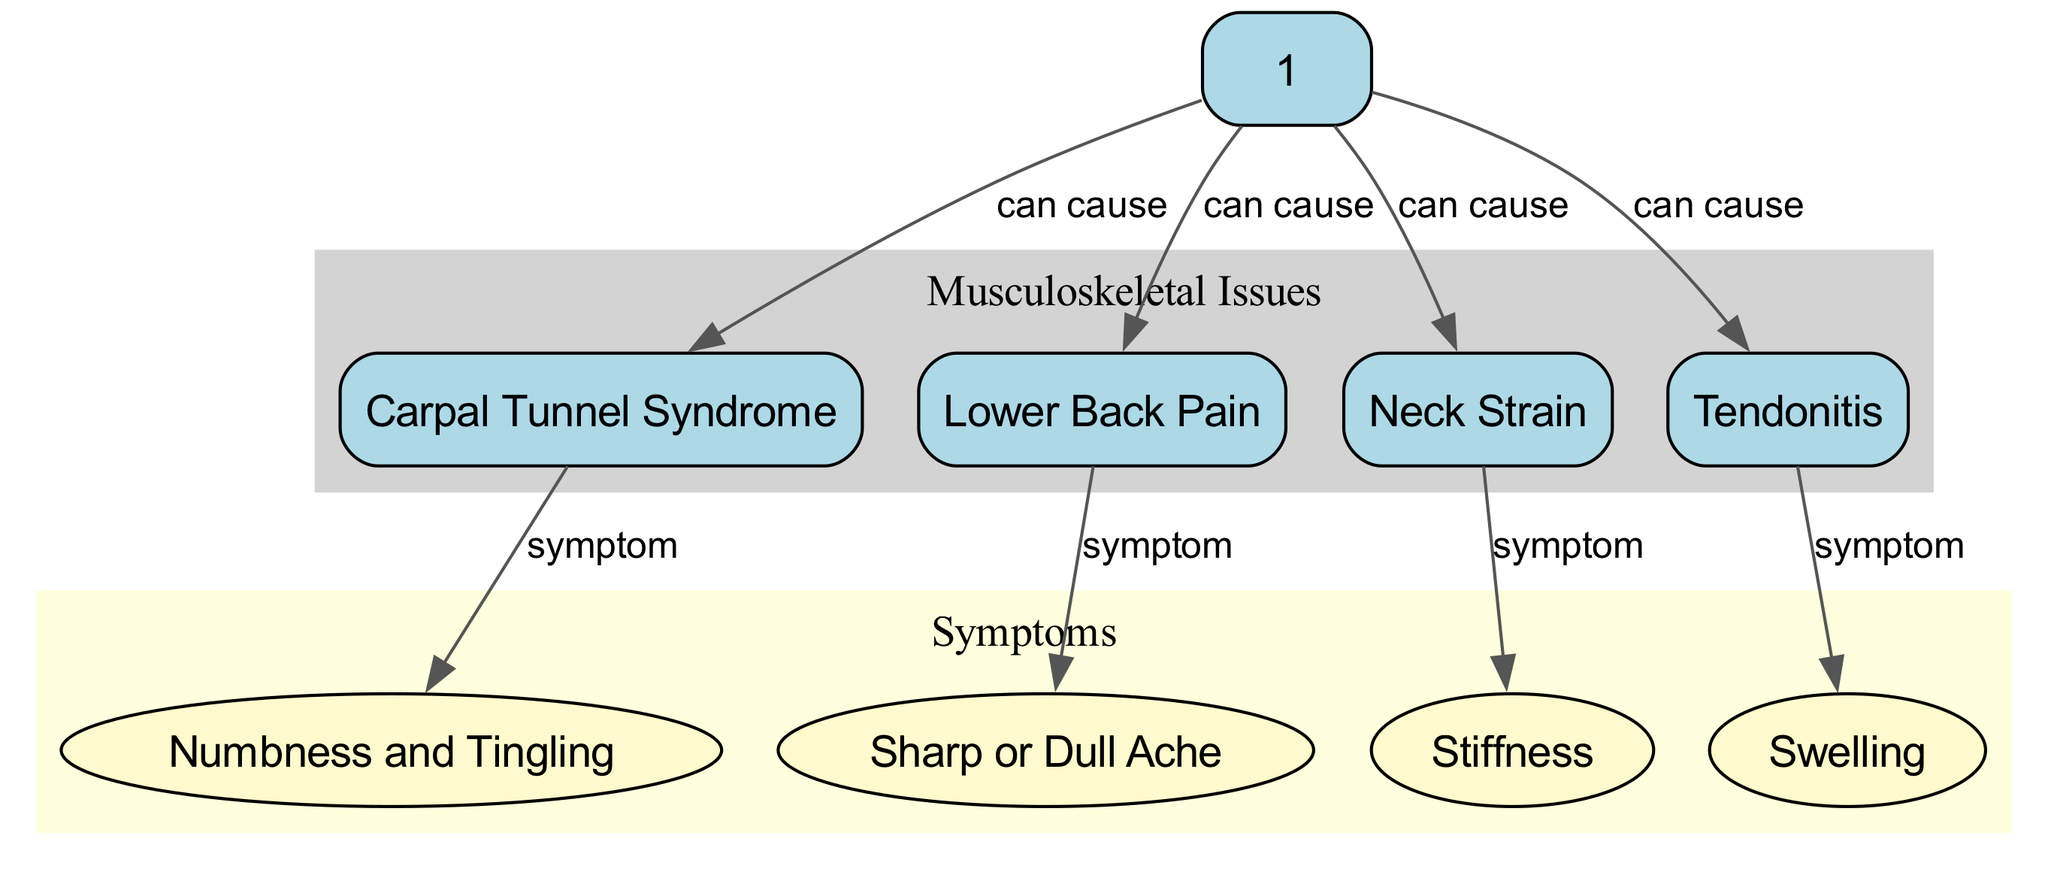What are the four musculoskeletal issues mentioned? The diagram lists four specific musculoskeletal issues which can be identified as nodes connected to the central node "Musculoskeletal Issues." These are Carpal Tunnel Syndrome, Lower Back Pain, Neck Strain, and Tendonitis.
Answer: Carpal Tunnel Syndrome, Lower Back Pain, Neck Strain, Tendonitis How many symptoms are identified in the diagram? The diagram includes four specific symptoms that are connected to the category "Symptoms." These symptoms are Numbness and Tingling, Sharp or Dull Ache, Stiffness, and Swelling, making a total of four symptoms.
Answer: 4 Which musculoskeletal issue is directly associated with the symptom "Numbness and Tingling"? The diagram shows a direct connection between Carpal Tunnel Syndrome and the symptom "Numbness and Tingling." This is represented as an edge from the Carpal Tunnel Syndrome node to the Numbness and Tingling node indicating this relationship.
Answer: Carpal Tunnel Syndrome What symptom is associated with Lower Back Pain? The diagram indicates that Lower Back Pain is associated with "Sharp or Dull Ache" as its symptom. This connection is depicted in the diagram by an edge that leads from the Lower Back Pain node to the Sharp or Dull Ache node.
Answer: Sharp or Dull Ache What does the edge labeled "can cause" indicate? The edges labeled "can cause" in the diagram signify that each linked musculoskeletal issue can lead to its corresponding symptoms. This indicates a causal relationship between the issues and their related symptoms, providing an understanding of how ergonomics impacts musculoskeletal health.
Answer: Causal relationship 